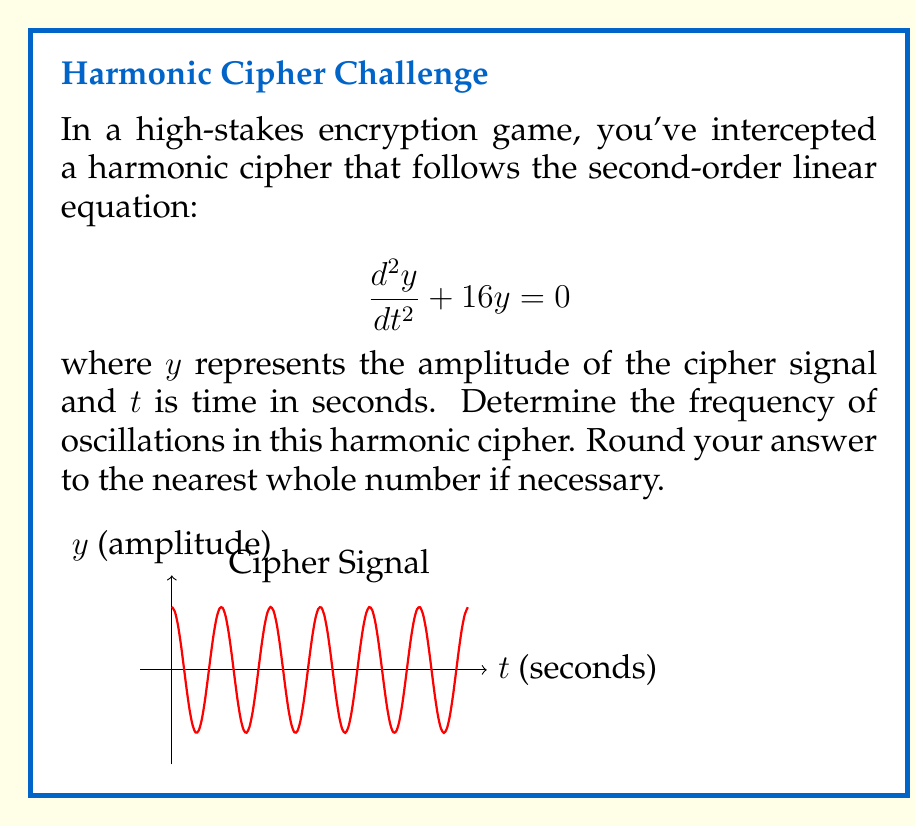Show me your answer to this math problem. To solve this problem, we'll follow these steps:

1) The general form of a second-order linear equation for simple harmonic motion is:

   $$\frac{d^2y}{dt^2} + \omega^2y = 0$$

   where $\omega$ is the angular frequency in radians per second.

2) Comparing our equation to the general form, we can see that:

   $$\omega^2 = 16$$

3) Solve for $\omega$:
   
   $$\omega = \sqrt{16} = 4 \text{ rad/s}$$

4) The relationship between angular frequency $\omega$ and frequency $f$ is:

   $$\omega = 2\pi f$$

5) Substitute the value of $\omega$ and solve for $f$:

   $$4 = 2\pi f$$
   $$f = \frac{4}{2\pi} \approx 0.6366 \text{ Hz}$$

6) Rounding to the nearest whole number:

   $$f \approx 1 \text{ Hz}$$

Therefore, the frequency of oscillations in the harmonic cipher is approximately 1 Hz.
Answer: 1 Hz 